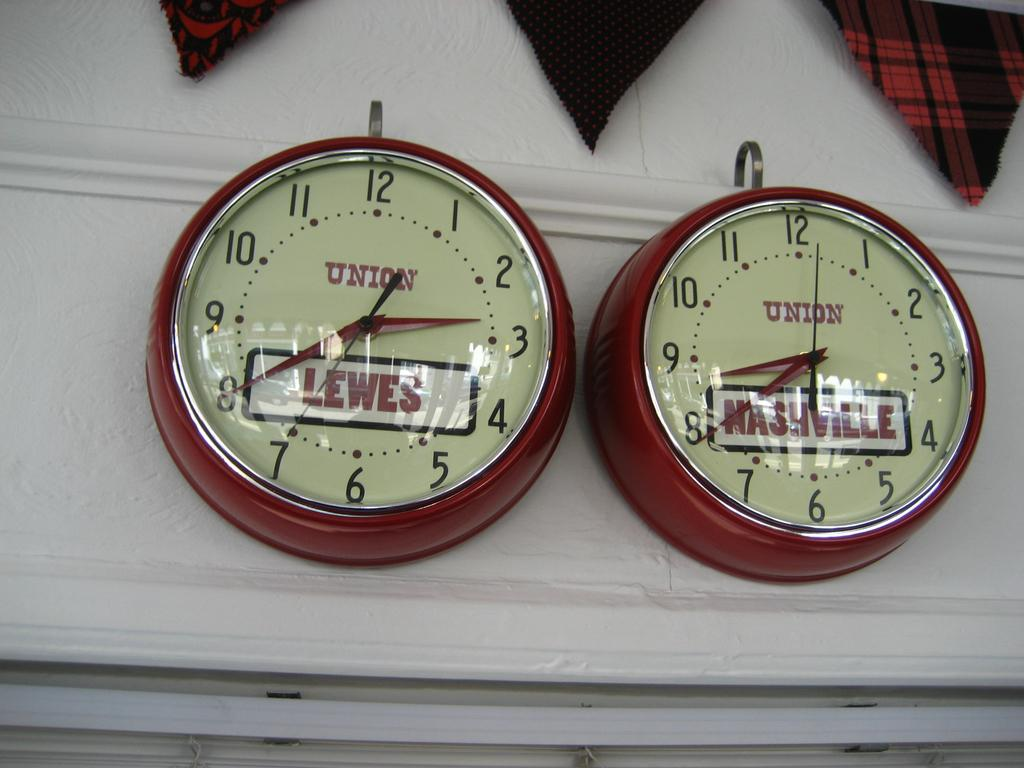<image>
Relay a brief, clear account of the picture shown. Two clocks are labeled with the word Union and city names. 